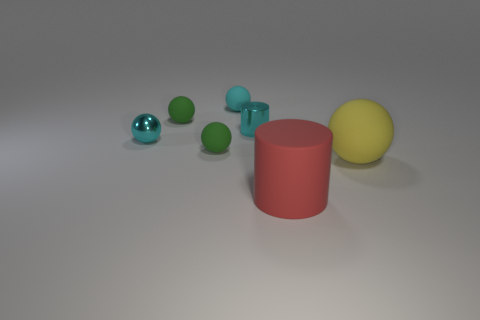Subtract all small metallic balls. How many balls are left? 4 Add 2 big brown blocks. How many objects exist? 9 Subtract all cylinders. How many objects are left? 5 Subtract all gray cubes. How many cyan spheres are left? 2 Subtract all tiny cylinders. Subtract all big yellow spheres. How many objects are left? 5 Add 5 small cyan matte spheres. How many small cyan matte spheres are left? 6 Add 2 large red rubber cylinders. How many large red rubber cylinders exist? 3 Subtract all green spheres. How many spheres are left? 3 Subtract 0 blue balls. How many objects are left? 7 Subtract 2 spheres. How many spheres are left? 3 